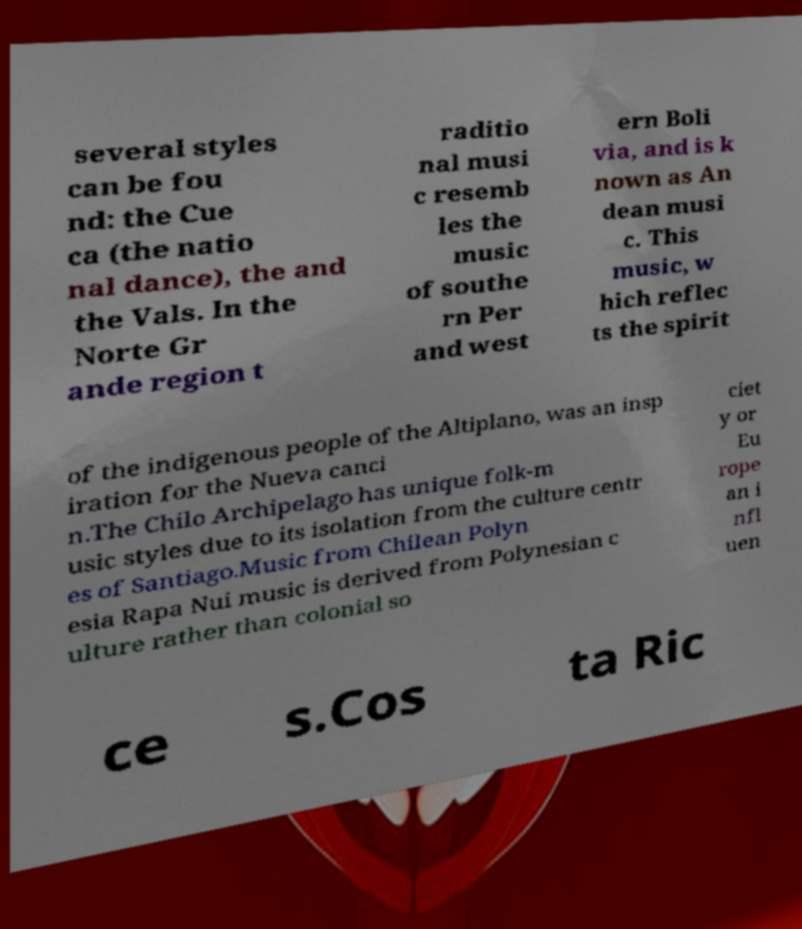I need the written content from this picture converted into text. Can you do that? several styles can be fou nd: the Cue ca (the natio nal dance), the and the Vals. In the Norte Gr ande region t raditio nal musi c resemb les the music of southe rn Per and west ern Boli via, and is k nown as An dean musi c. This music, w hich reflec ts the spirit of the indigenous people of the Altiplano, was an insp iration for the Nueva canci n.The Chilo Archipelago has unique folk-m usic styles due to its isolation from the culture centr es of Santiago.Music from Chilean Polyn esia Rapa Nui music is derived from Polynesian c ulture rather than colonial so ciet y or Eu rope an i nfl uen ce s.Cos ta Ric 